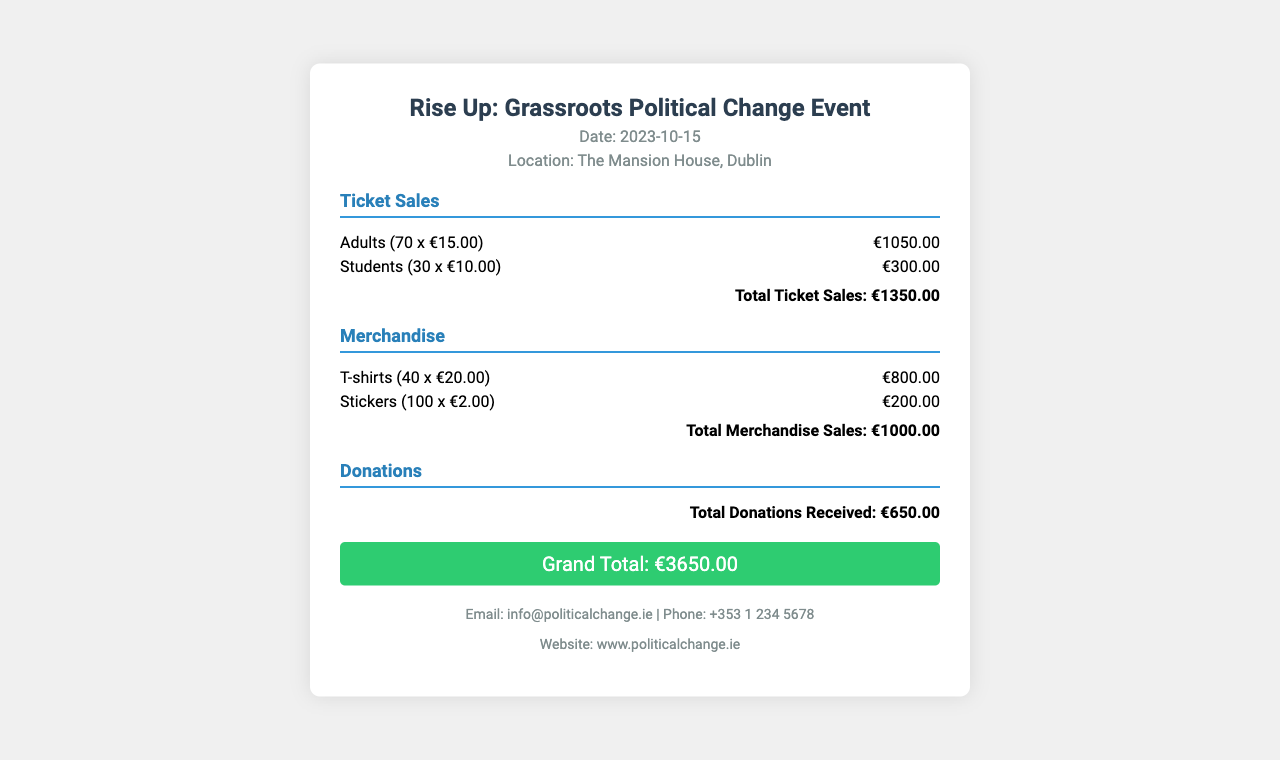What is the date of the event? The date of the event is specified in the document header.
Answer: 2023-10-15 Where was the event held? The location of the event is mentioned in the document header.
Answer: The Mansion House, Dublin What is the total amount raised from ticket sales? The total ticket sales are itemized, and the sum is provided at the end of that section.
Answer: €1350.00 How much did merchandise sales total? The total for merchandise is detailed and summed at the end of that section.
Answer: €1000.00 What is the total amount received in donations? The total donations received are stated in the donations section.
Answer: €650.00 What is the grand total of all revenues? The grand total combines all revenue sources and is provided at the end of the receipt.
Answer: €3650.00 How many adults attended the event? The number of adults is specified in the ticket sales section.
Answer: 70 What item sold for the highest total? The merchandise section indicates which item had the highest sales figure.
Answer: T-shirts How many stickers were sold? The number of stickers sold is detailed in the merchandise section.
Answer: 100 What is the contact email provided? The contact email is listed at the bottom of the document.
Answer: info@politicalchange.ie 